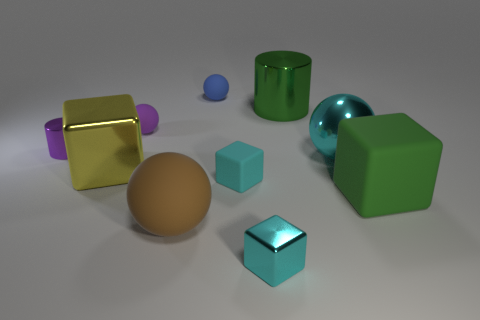Subtract all big brown balls. How many balls are left? 3 Subtract 4 spheres. How many spheres are left? 0 Subtract all gray cylinders. How many cyan cubes are left? 2 Subtract all brown spheres. How many spheres are left? 3 Subtract all blocks. How many objects are left? 6 Subtract all cyan cubes. Subtract all yellow balls. How many cubes are left? 2 Subtract all spheres. Subtract all tiny cyan matte cubes. How many objects are left? 5 Add 8 cylinders. How many cylinders are left? 10 Add 2 large shiny cubes. How many large shiny cubes exist? 3 Subtract 1 green cylinders. How many objects are left? 9 